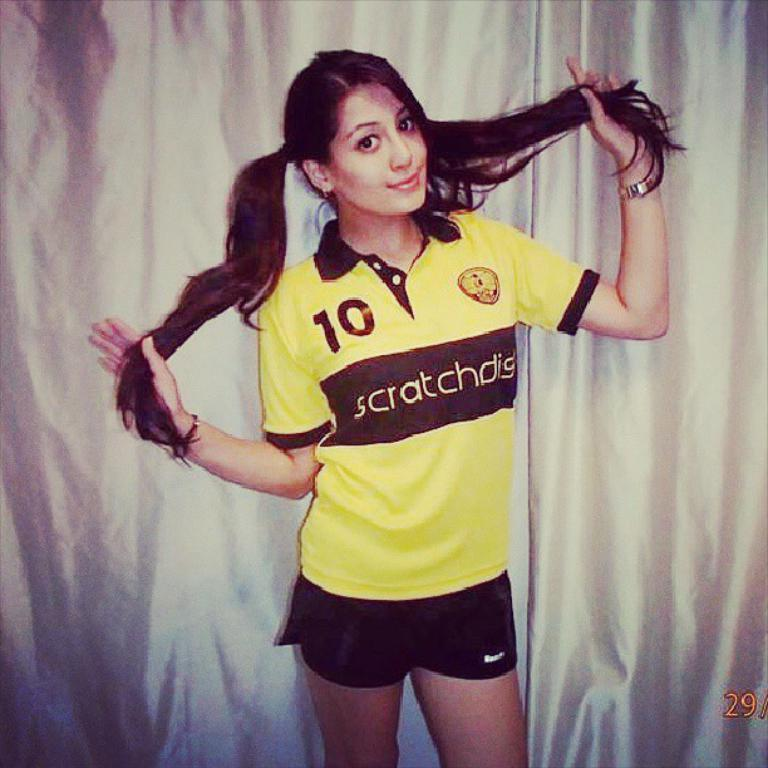<image>
Describe the image concisely. the number 10 is on the jersey of a person 